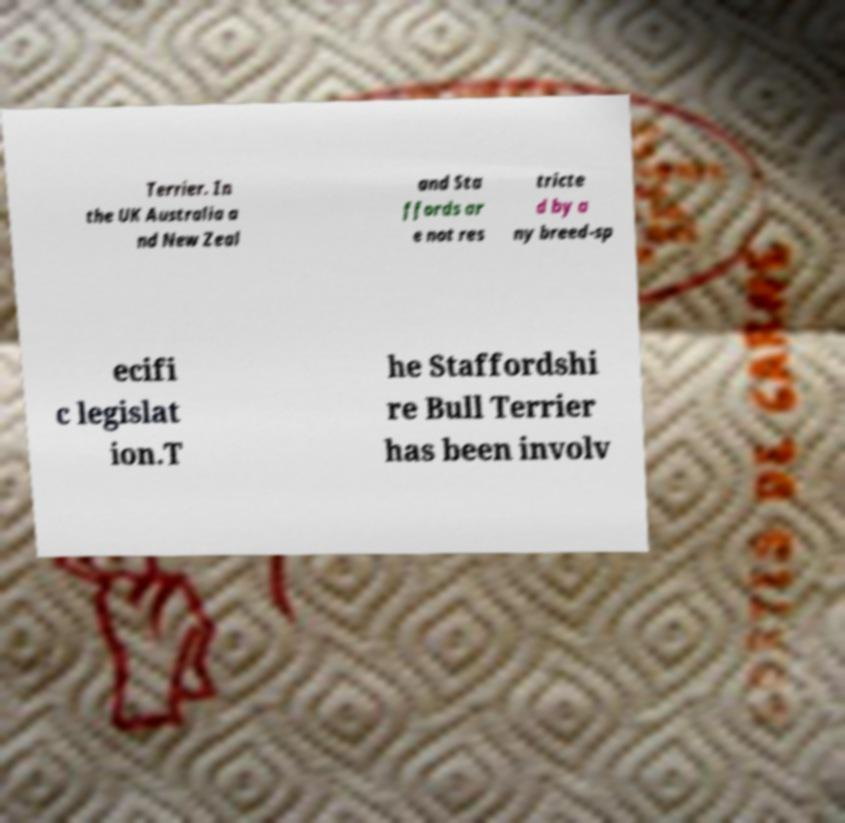Can you accurately transcribe the text from the provided image for me? Terrier. In the UK Australia a nd New Zeal and Sta ffords ar e not res tricte d by a ny breed-sp ecifi c legislat ion.T he Staffordshi re Bull Terrier has been involv 